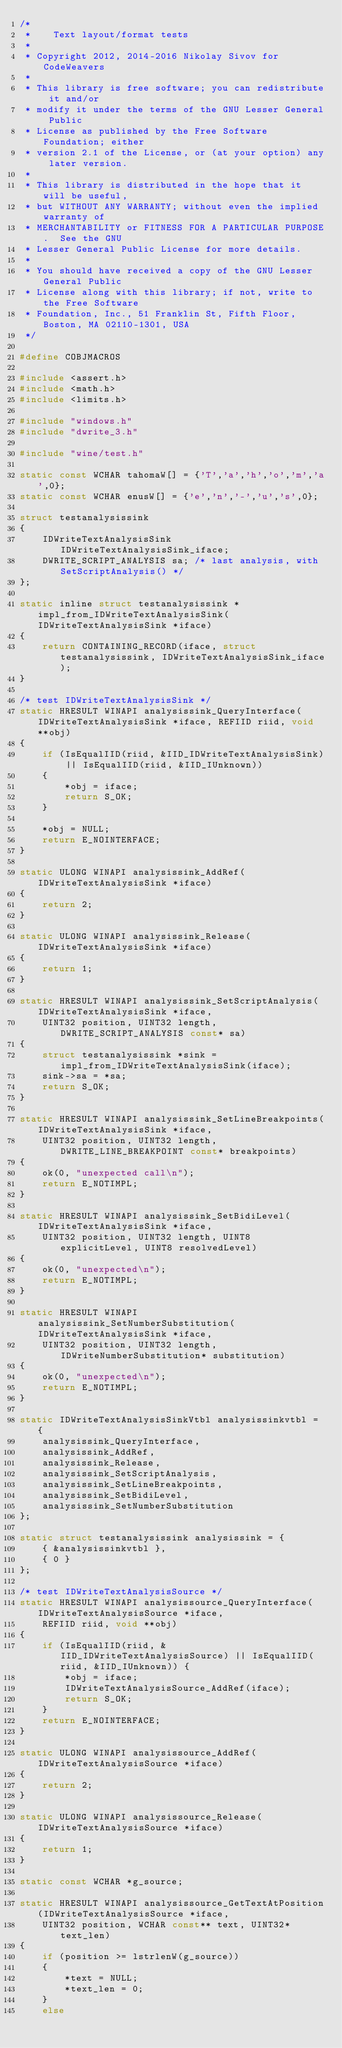Convert code to text. <code><loc_0><loc_0><loc_500><loc_500><_C_>/*
 *    Text layout/format tests
 *
 * Copyright 2012, 2014-2016 Nikolay Sivov for CodeWeavers
 *
 * This library is free software; you can redistribute it and/or
 * modify it under the terms of the GNU Lesser General Public
 * License as published by the Free Software Foundation; either
 * version 2.1 of the License, or (at your option) any later version.
 *
 * This library is distributed in the hope that it will be useful,
 * but WITHOUT ANY WARRANTY; without even the implied warranty of
 * MERCHANTABILITY or FITNESS FOR A PARTICULAR PURPOSE.  See the GNU
 * Lesser General Public License for more details.
 *
 * You should have received a copy of the GNU Lesser General Public
 * License along with this library; if not, write to the Free Software
 * Foundation, Inc., 51 Franklin St, Fifth Floor, Boston, MA 02110-1301, USA
 */

#define COBJMACROS

#include <assert.h>
#include <math.h>
#include <limits.h>

#include "windows.h"
#include "dwrite_3.h"

#include "wine/test.h"

static const WCHAR tahomaW[] = {'T','a','h','o','m','a',0};
static const WCHAR enusW[] = {'e','n','-','u','s',0};

struct testanalysissink
{
    IDWriteTextAnalysisSink IDWriteTextAnalysisSink_iface;
    DWRITE_SCRIPT_ANALYSIS sa; /* last analysis, with SetScriptAnalysis() */
};

static inline struct testanalysissink *impl_from_IDWriteTextAnalysisSink(IDWriteTextAnalysisSink *iface)
{
    return CONTAINING_RECORD(iface, struct testanalysissink, IDWriteTextAnalysisSink_iface);
}

/* test IDWriteTextAnalysisSink */
static HRESULT WINAPI analysissink_QueryInterface(IDWriteTextAnalysisSink *iface, REFIID riid, void **obj)
{
    if (IsEqualIID(riid, &IID_IDWriteTextAnalysisSink) || IsEqualIID(riid, &IID_IUnknown))
    {
        *obj = iface;
        return S_OK;
    }

    *obj = NULL;
    return E_NOINTERFACE;
}

static ULONG WINAPI analysissink_AddRef(IDWriteTextAnalysisSink *iface)
{
    return 2;
}

static ULONG WINAPI analysissink_Release(IDWriteTextAnalysisSink *iface)
{
    return 1;
}

static HRESULT WINAPI analysissink_SetScriptAnalysis(IDWriteTextAnalysisSink *iface,
    UINT32 position, UINT32 length, DWRITE_SCRIPT_ANALYSIS const* sa)
{
    struct testanalysissink *sink = impl_from_IDWriteTextAnalysisSink(iface);
    sink->sa = *sa;
    return S_OK;
}

static HRESULT WINAPI analysissink_SetLineBreakpoints(IDWriteTextAnalysisSink *iface,
    UINT32 position, UINT32 length, DWRITE_LINE_BREAKPOINT const* breakpoints)
{
    ok(0, "unexpected call\n");
    return E_NOTIMPL;
}

static HRESULT WINAPI analysissink_SetBidiLevel(IDWriteTextAnalysisSink *iface,
    UINT32 position, UINT32 length, UINT8 explicitLevel, UINT8 resolvedLevel)
{
    ok(0, "unexpected\n");
    return E_NOTIMPL;
}

static HRESULT WINAPI analysissink_SetNumberSubstitution(IDWriteTextAnalysisSink *iface,
    UINT32 position, UINT32 length, IDWriteNumberSubstitution* substitution)
{
    ok(0, "unexpected\n");
    return E_NOTIMPL;
}

static IDWriteTextAnalysisSinkVtbl analysissinkvtbl = {
    analysissink_QueryInterface,
    analysissink_AddRef,
    analysissink_Release,
    analysissink_SetScriptAnalysis,
    analysissink_SetLineBreakpoints,
    analysissink_SetBidiLevel,
    analysissink_SetNumberSubstitution
};

static struct testanalysissink analysissink = {
    { &analysissinkvtbl },
    { 0 }
};

/* test IDWriteTextAnalysisSource */
static HRESULT WINAPI analysissource_QueryInterface(IDWriteTextAnalysisSource *iface,
    REFIID riid, void **obj)
{
    if (IsEqualIID(riid, &IID_IDWriteTextAnalysisSource) || IsEqualIID(riid, &IID_IUnknown)) {
        *obj = iface;
        IDWriteTextAnalysisSource_AddRef(iface);
        return S_OK;
    }
    return E_NOINTERFACE;
}

static ULONG WINAPI analysissource_AddRef(IDWriteTextAnalysisSource *iface)
{
    return 2;
}

static ULONG WINAPI analysissource_Release(IDWriteTextAnalysisSource *iface)
{
    return 1;
}

static const WCHAR *g_source;

static HRESULT WINAPI analysissource_GetTextAtPosition(IDWriteTextAnalysisSource *iface,
    UINT32 position, WCHAR const** text, UINT32* text_len)
{
    if (position >= lstrlenW(g_source))
    {
        *text = NULL;
        *text_len = 0;
    }
    else</code> 